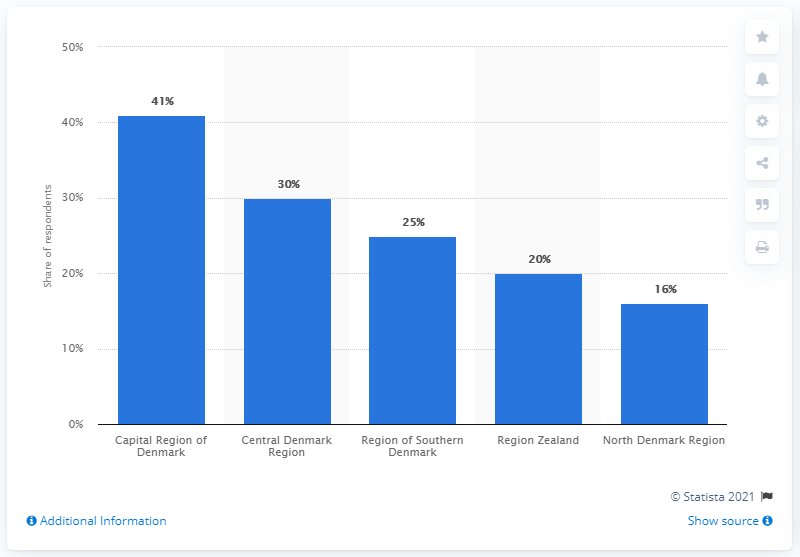Point out several critical features in this image. According to the survey conducted by Dansk Industri, the majority of respondents who lived in the Capital Region of Denmark. 